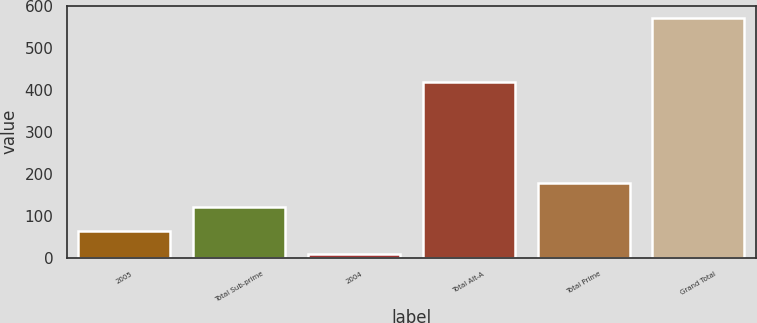<chart> <loc_0><loc_0><loc_500><loc_500><bar_chart><fcel>2005<fcel>Total Sub-prime<fcel>2004<fcel>Total Alt-A<fcel>Total Prime<fcel>Grand Total<nl><fcel>64.5<fcel>121<fcel>8<fcel>420<fcel>177.5<fcel>573<nl></chart> 